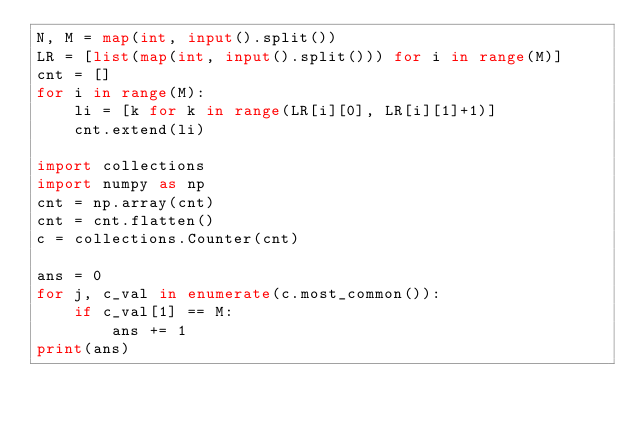<code> <loc_0><loc_0><loc_500><loc_500><_Python_>N, M = map(int, input().split())
LR = [list(map(int, input().split())) for i in range(M)]
cnt = []
for i in range(M):
    li = [k for k in range(LR[i][0], LR[i][1]+1)]
    cnt.extend(li)
    
import collections
import numpy as np
cnt = np.array(cnt)
cnt = cnt.flatten()
c = collections.Counter(cnt)

ans = 0
for j, c_val in enumerate(c.most_common()):
    if c_val[1] == M:
        ans += 1
print(ans)</code> 